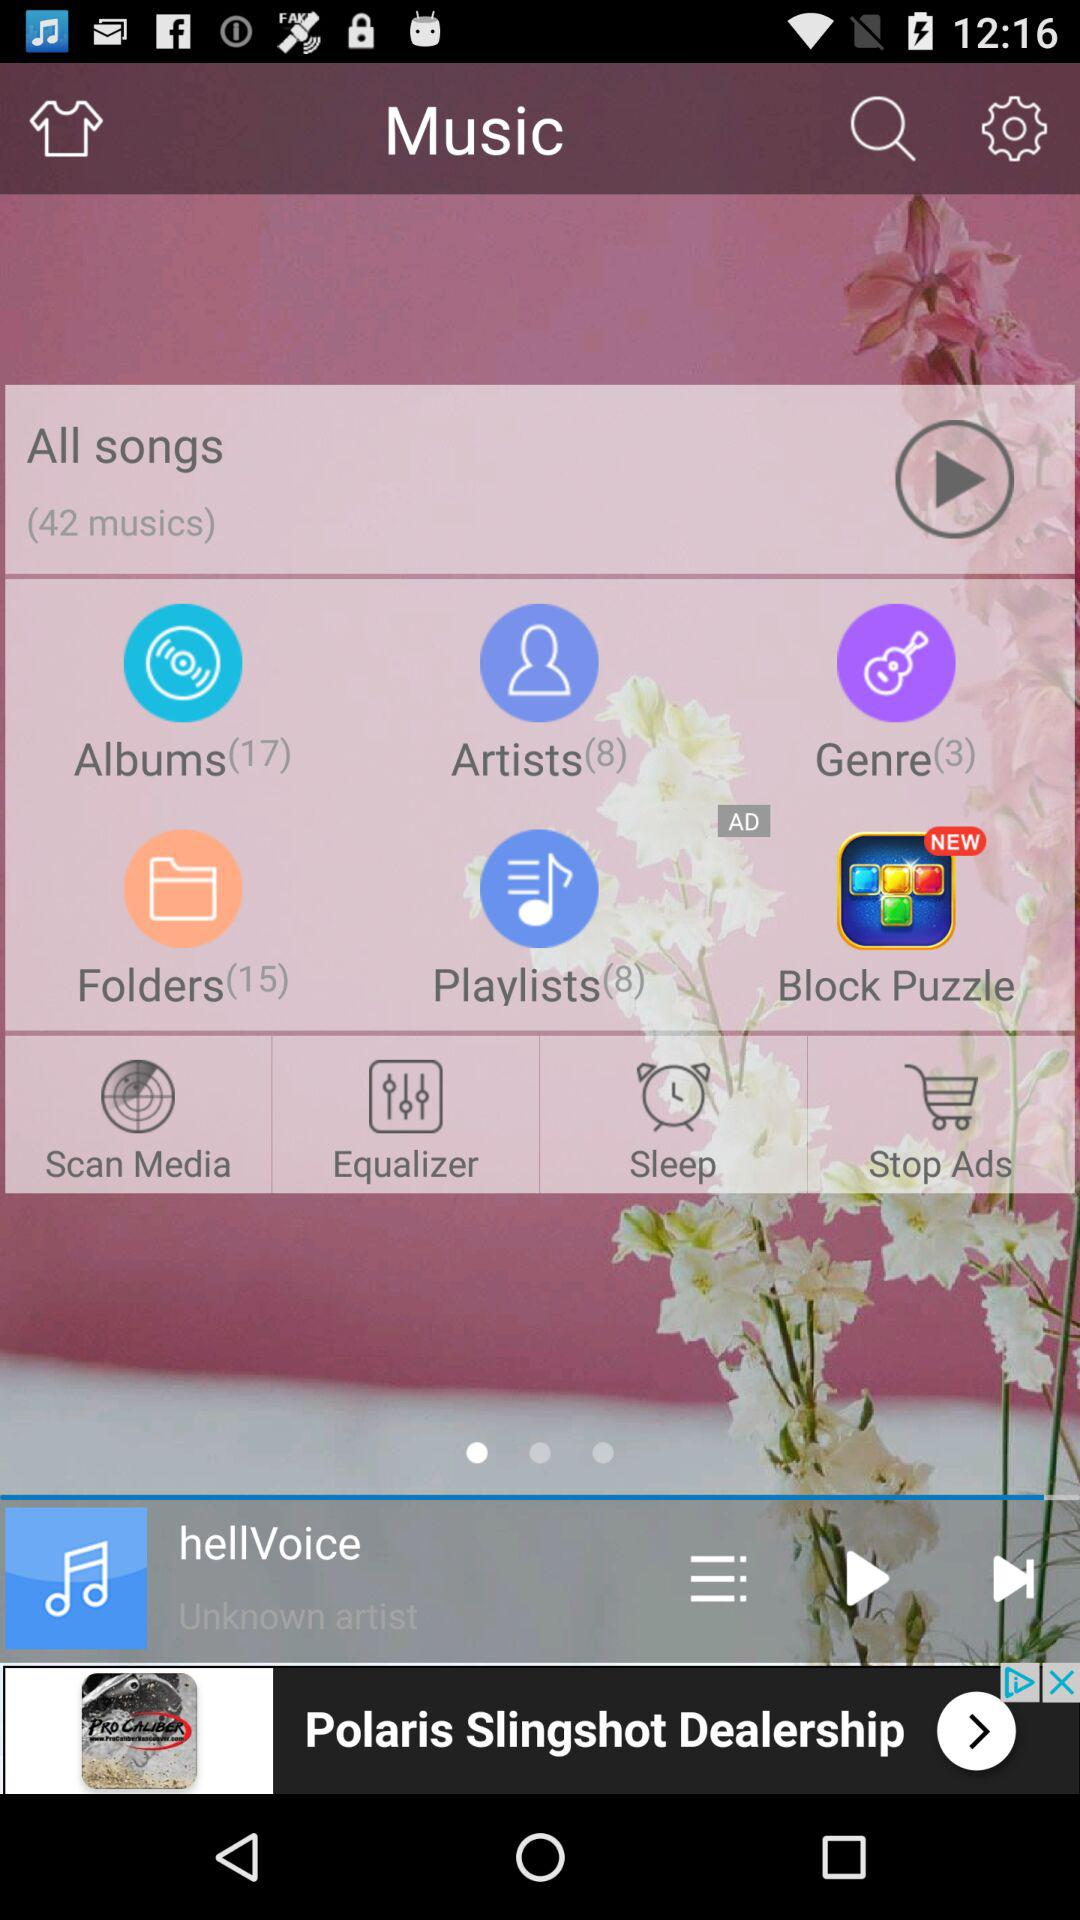How many songs are there? There are 42 songs. 